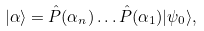<formula> <loc_0><loc_0><loc_500><loc_500>| \alpha \rangle = \hat { P } ( \alpha _ { n } ) \dots \hat { P } ( \alpha _ { 1 } ) | \psi _ { 0 } \rangle ,</formula> 